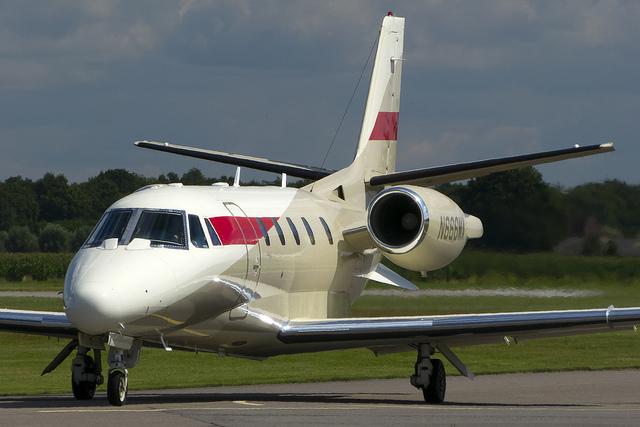How many jets does the plane have?
Short answer required. 2. What color is the plane?
Concise answer only. White. Is this a private jet?
Answer briefly. Yes. Is the plane leaving or arriving?
Short answer required. Leaving. 